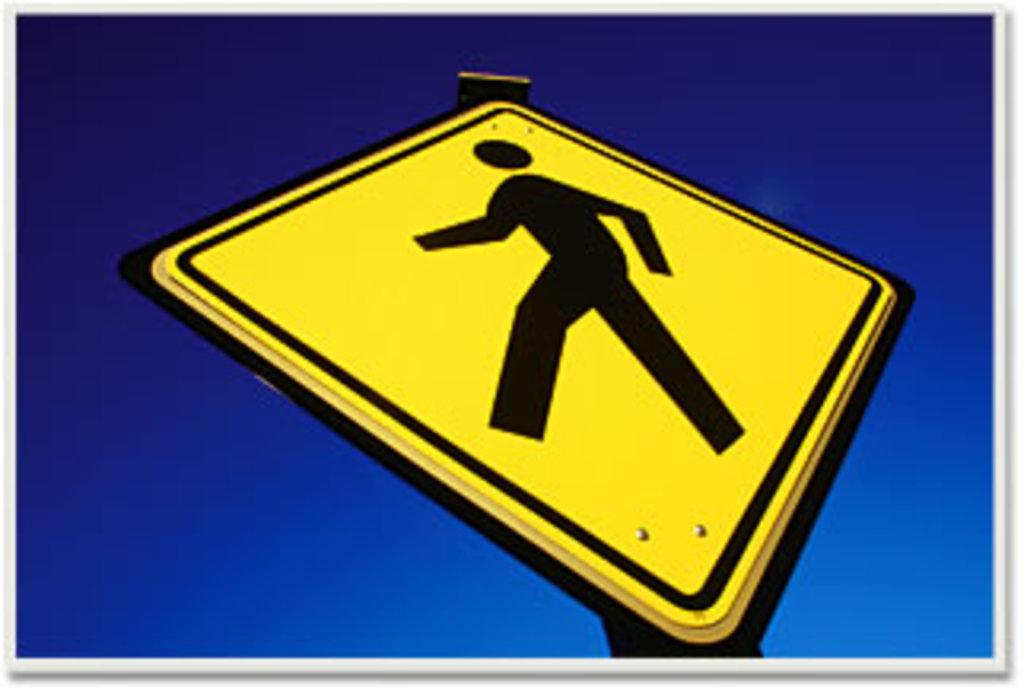What is the main object in the center of the image? There is a sign board in the center of the image. What color is the background of the image? The background of the image is blue. Is there any border around the image? Yes, there is a white colored border around the image. Does the sign board have a pet in the image? There is no pet present in the image, as it features a sign board with a blue background and a white border. 